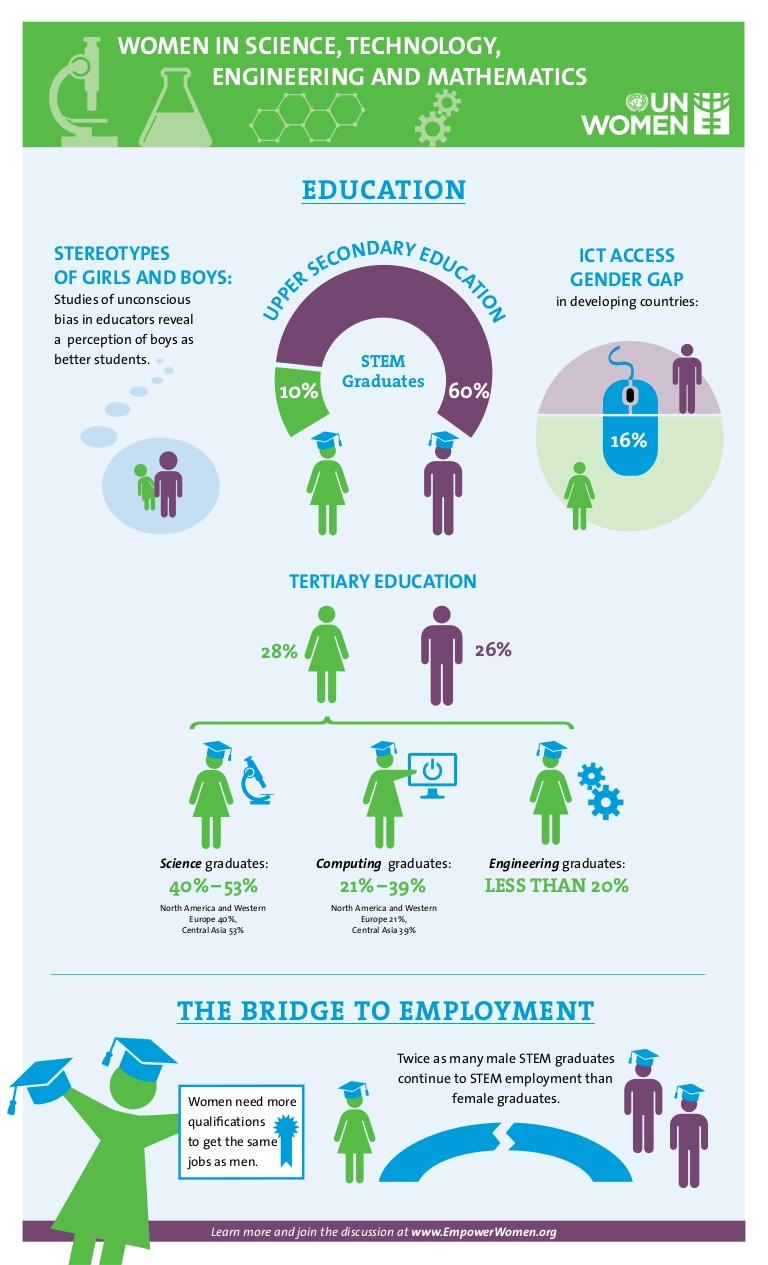Give some essential details in this illustration. A large percentage of men who graduate with a degree in STEM fields are 60%. Only a small percentage of female stem graduates come from an engineering background, less than 20%. The gender gap in ICT access in developing countries is 16%. According to a recent survey, only 10% of women who graduate with a degree in STEM (science, technology, engineering, and mathematics) fields are successful in their careers. 